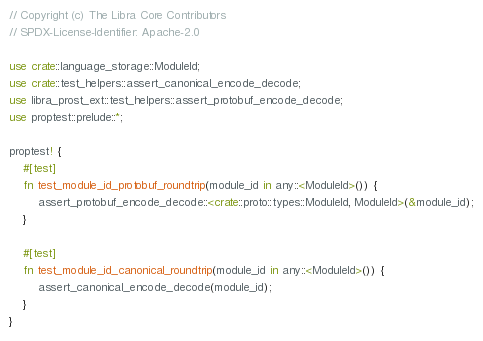<code> <loc_0><loc_0><loc_500><loc_500><_Rust_>// Copyright (c) The Libra Core Contributors
// SPDX-License-Identifier: Apache-2.0

use crate::language_storage::ModuleId;
use crate::test_helpers::assert_canonical_encode_decode;
use libra_prost_ext::test_helpers::assert_protobuf_encode_decode;
use proptest::prelude::*;

proptest! {
    #[test]
    fn test_module_id_protobuf_roundtrip(module_id in any::<ModuleId>()) {
        assert_protobuf_encode_decode::<crate::proto::types::ModuleId, ModuleId>(&module_id);
    }

    #[test]
    fn test_module_id_canonical_roundtrip(module_id in any::<ModuleId>()) {
        assert_canonical_encode_decode(module_id);
    }
}
</code> 